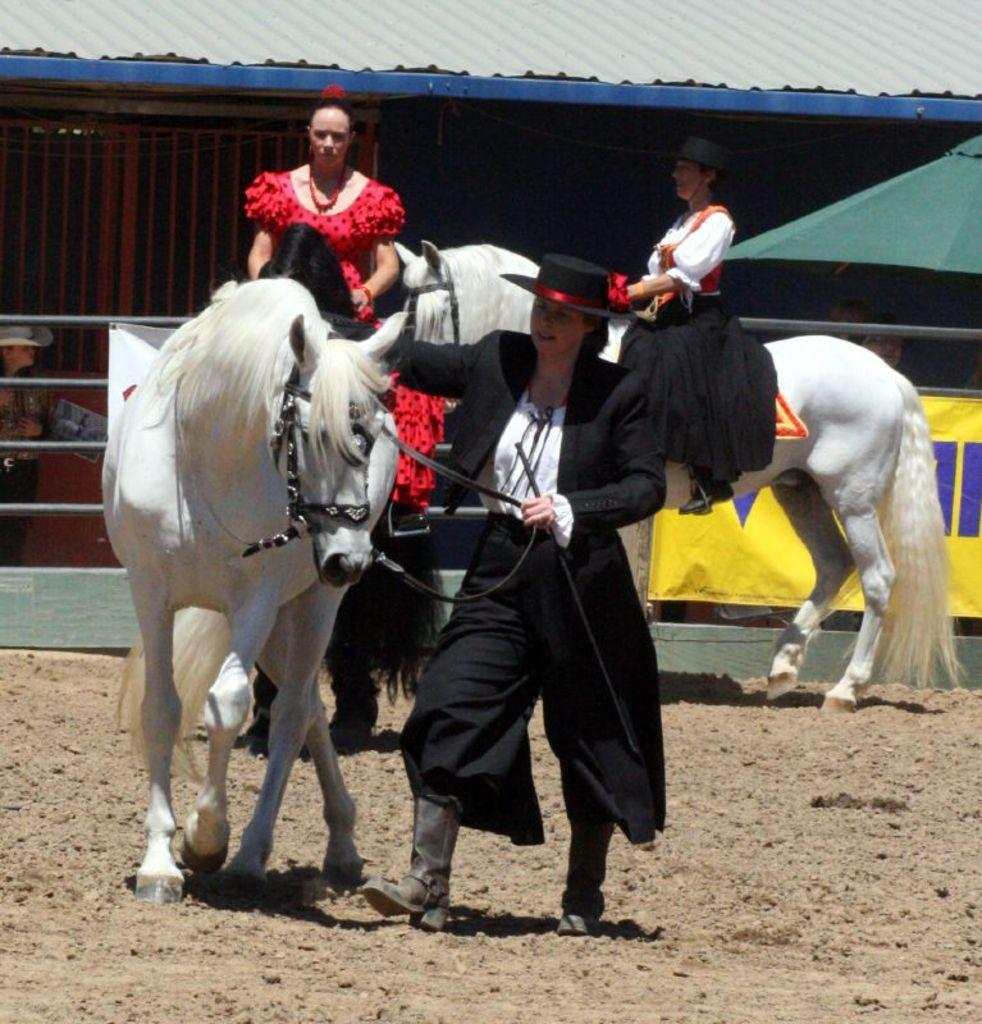How many people are on the horse in the image? There are two persons sitting on a horse in the image. What is the standing person doing in the image? The standing person is nearby, but their actions are not specified. Can you describe the appearance of the standing person? The standing person is wearing a cap. What can be seen in the background of the image? There is a shed and a banner in the background. How many birds are perched on the tiger's back in the image? There are no birds or tigers present in the image. What type of sponge is being used by the person sitting on the horse? There is no sponge visible in the image. 